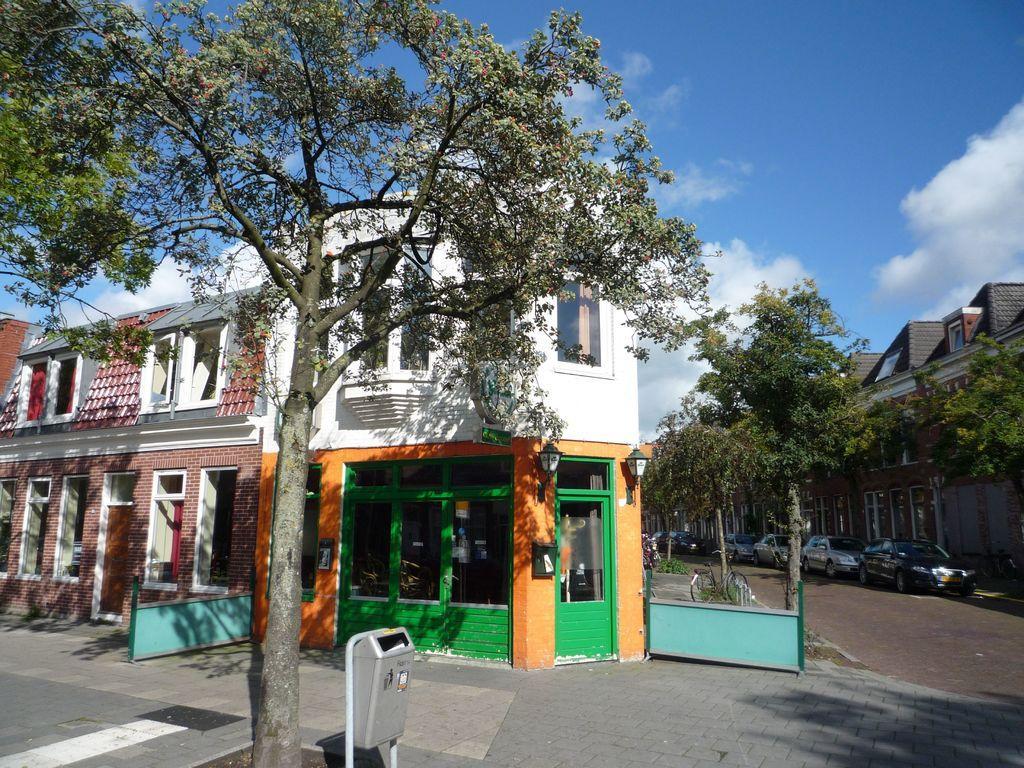How would you summarize this image in a sentence or two? In this image I can see in the middle there is a house, there are trees. On the right side few cars are parked on the road. At the top it is the blue color sky. 